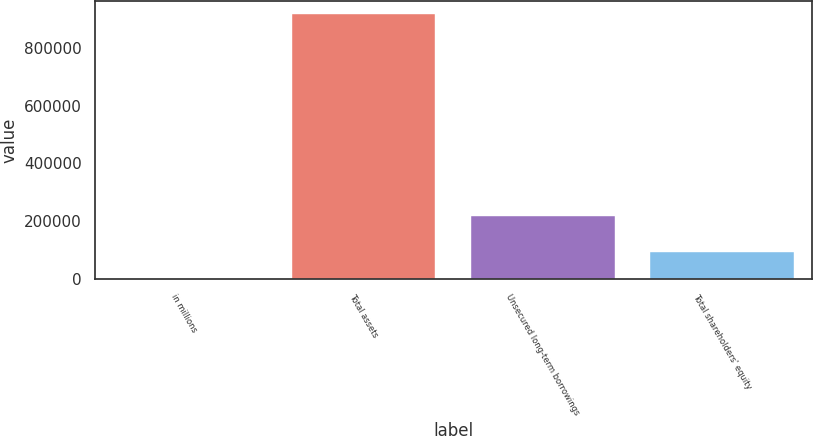Convert chart. <chart><loc_0><loc_0><loc_500><loc_500><bar_chart><fcel>in millions<fcel>Total assets<fcel>Unsecured long-term borrowings<fcel>Total shareholders' equity<nl><fcel>2017<fcel>916776<fcel>217687<fcel>93492.9<nl></chart> 